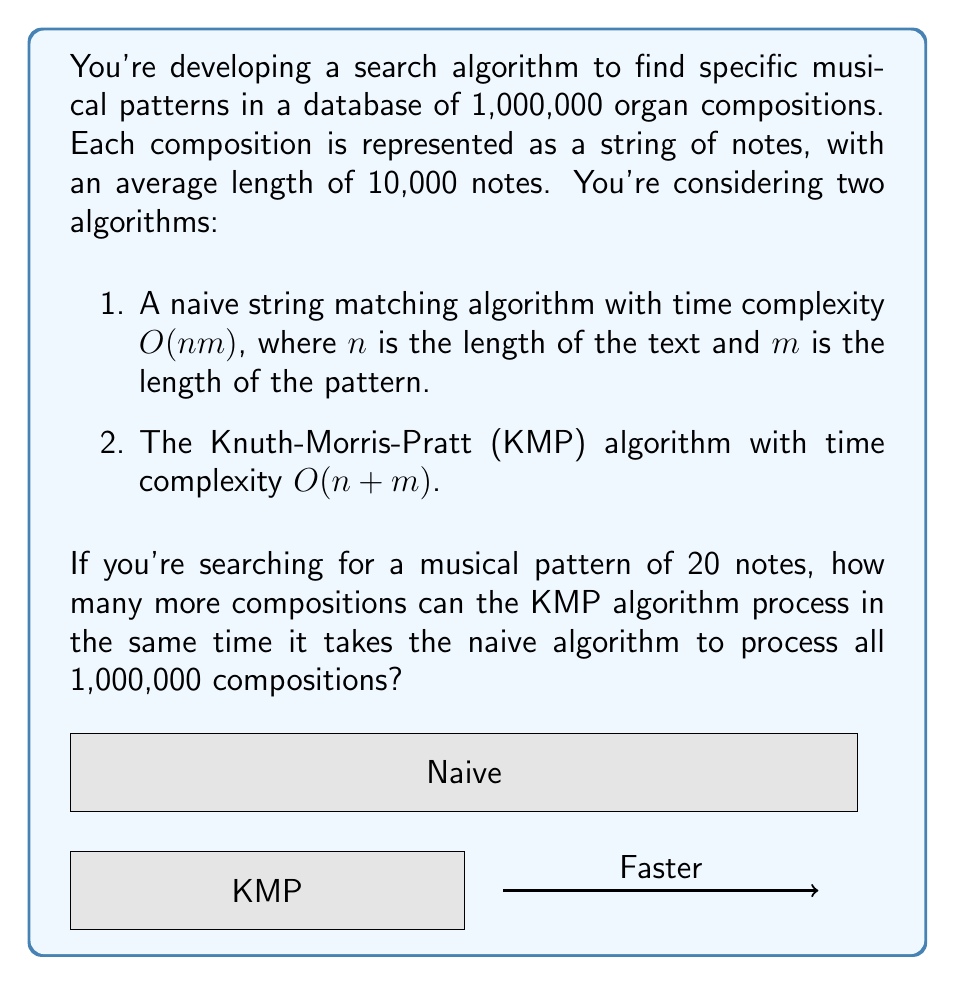Show me your answer to this math problem. Let's approach this step-by-step:

1) First, calculate the time taken by the naive algorithm:
   - For each composition: $O(nm) = O(10000 \times 20) = O(200000)$
   - For all 1,000,000 compositions: $O(200000 \times 1000000) = O(2 \times 10^{11})$

2) Now, calculate the time taken by the KMP algorithm:
   - For each composition: $O(n+m) = O(10000 + 20) \approx O(10000)$
   - Let $x$ be the number of compositions KMP can process in the same time
   - So, $O(10000x) = O(2 \times 10^{11})$

3) Solve for $x$:
   $10000x = 2 \times 10^{11}$
   $x = \frac{2 \times 10^{11}}{10000} = 2 \times 10^7 = 20,000,000$

4) Calculate the difference:
   $20,000,000 - 1,000,000 = 19,000,000$

Therefore, the KMP algorithm can process 19,000,000 more compositions in the same time.
Answer: 19,000,000 compositions 